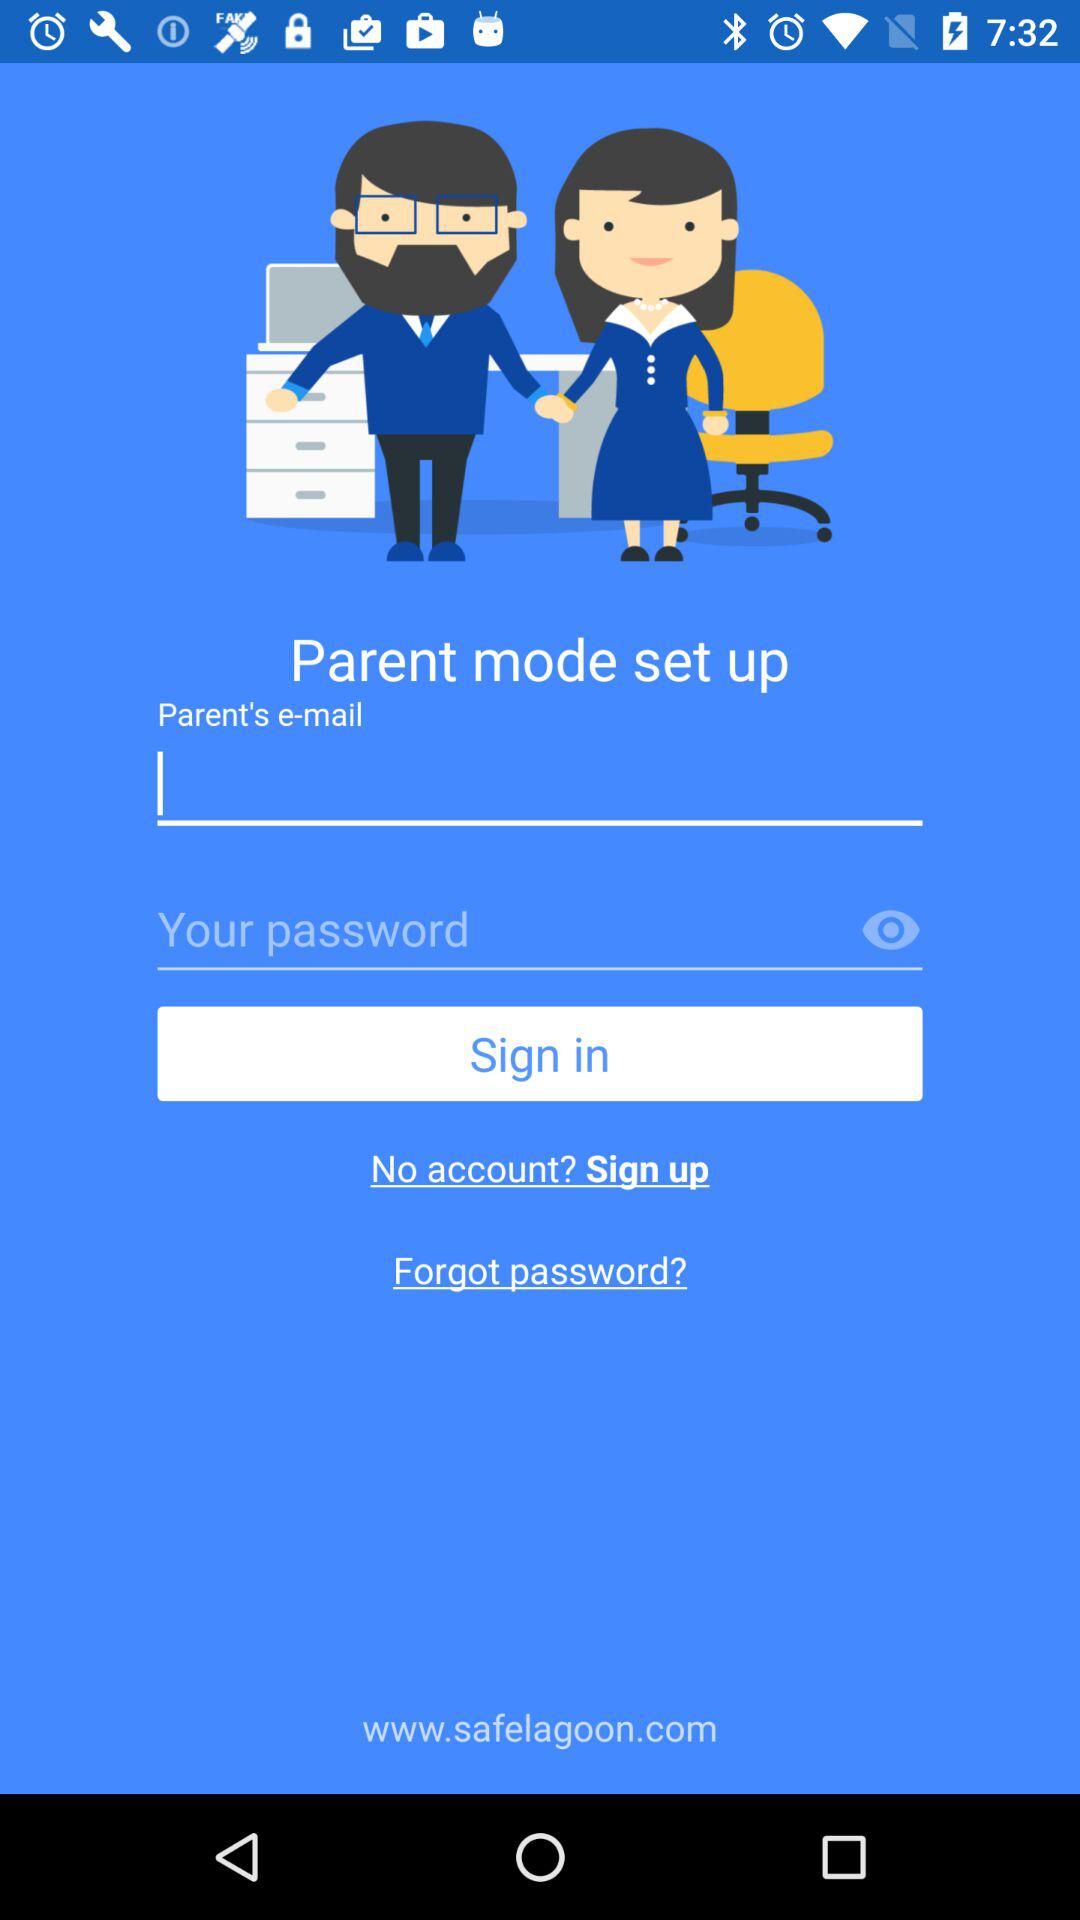What is the web address? The web address is www.safelagoon.com. 